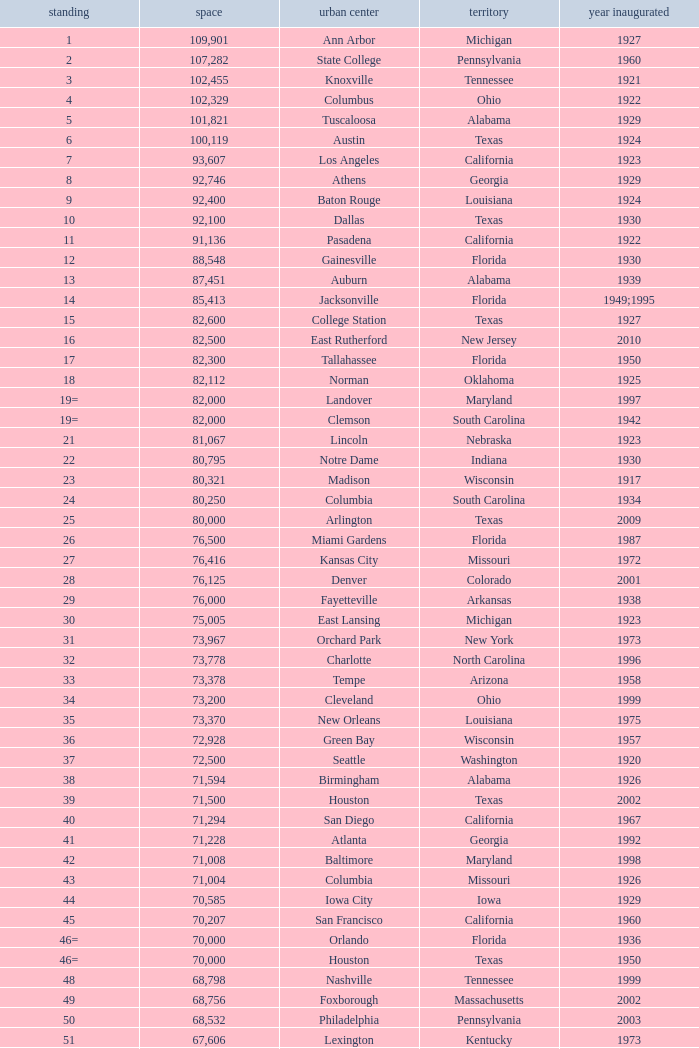What is the city in Alabama that opened in 1996? Huntsville. 